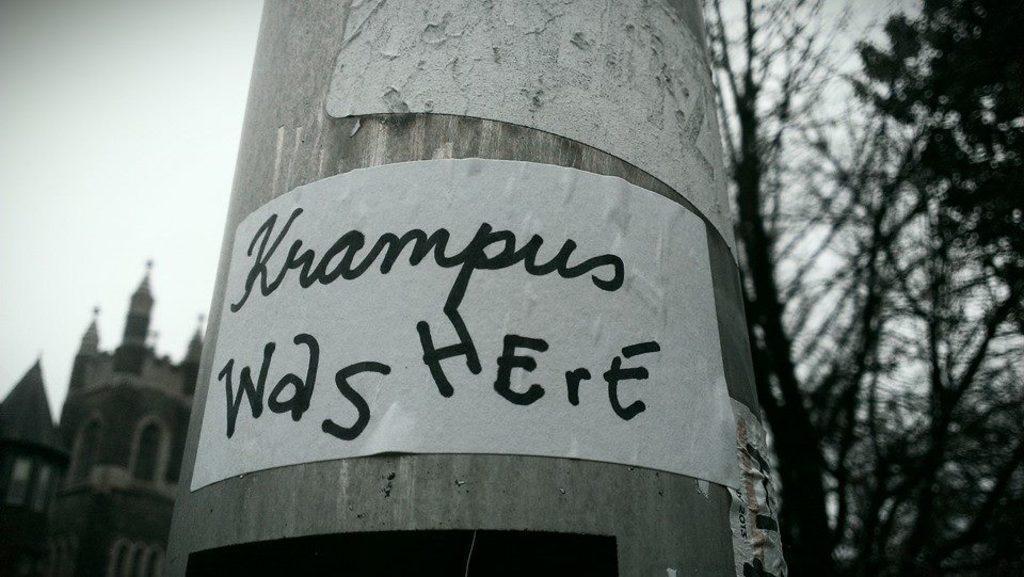Describe this image in one or two sentences. This is a black and white image. In this image we can see some papers pasted on a pole. On the backside we can see the branches of a tree, a building and the sky. 